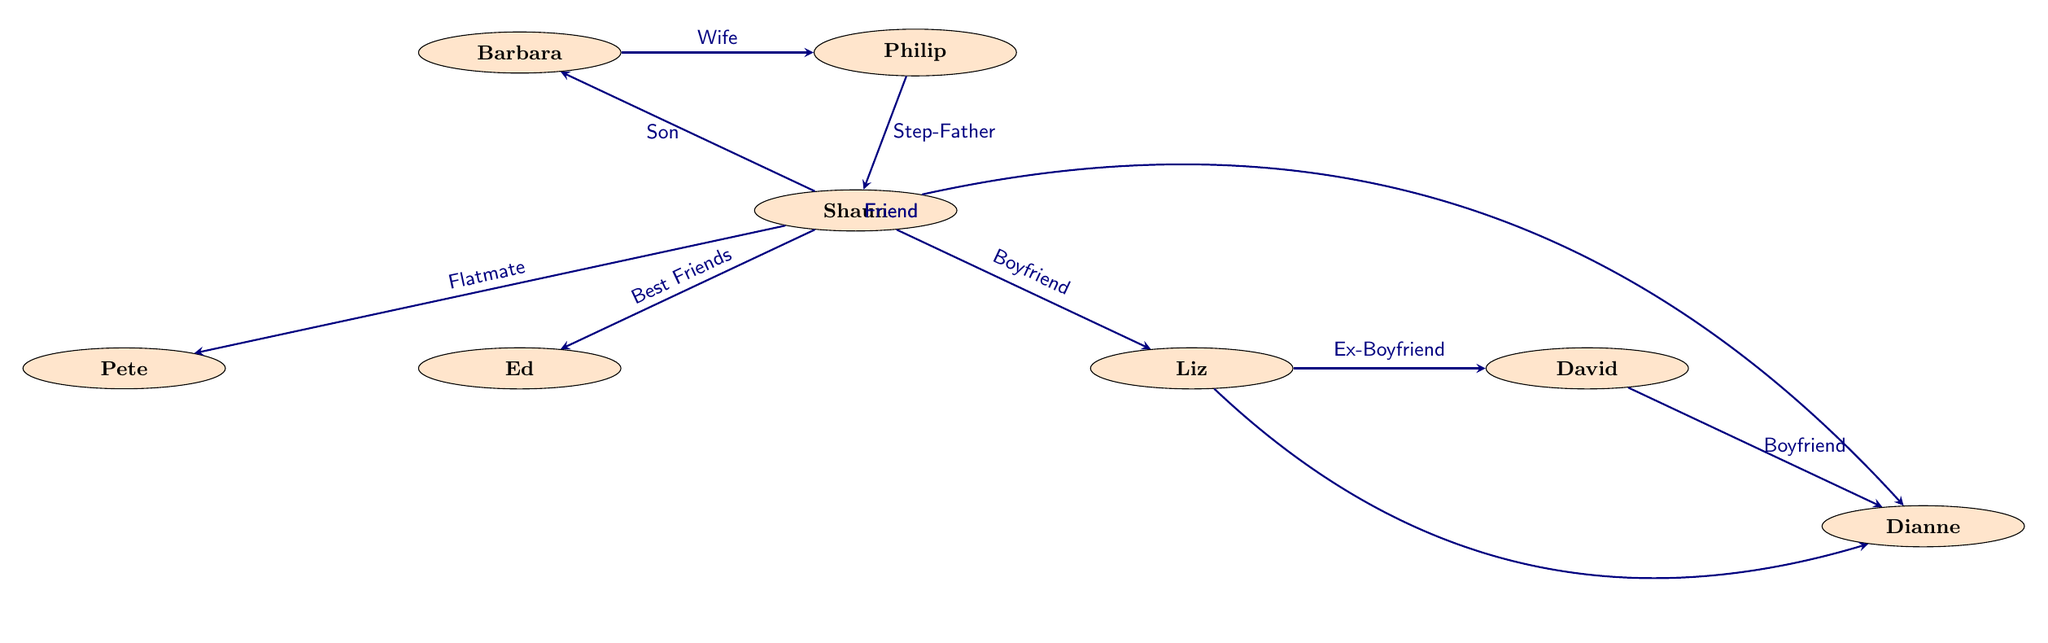What is the relationship between Shaun and Ed? The diagram indicates that Shaun and Ed have a "Best Friends" relationship. This information is directly displayed by the arrow connecting Shaun to Ed, labeled with the relationship type.
Answer: Best Friends How many characters are in the diagram? By counting the nodes labeled with character names, we find there are eight distinct characters represented in the diagram.
Answer: 8 What type of relationship exists between Liz and David? The diagram shows an arrow from Liz to David labeled "Ex-Boyfriend," indicating their previous romantic connection.
Answer: Ex-Boyfriend Who is Shaun's step-father? The diagram states that Philip is Shaun's step-father, as indicated by the arrow connecting Philip to Shaun labeled "Step-Father."
Answer: Philip Which character is both Shaun's flatmate and his friend? The diagram shows Shaun as having a flatmate relationship with Pete, while Dianne is noted as a friend of Shaun through a separate relationship arrow. However, only Pete is labeled as a flatmate. Thus, only Pete is Shaun's flatmate and he isn't labeled as a friend.
Answer: Pete How many relationships connect to Shaun? To find the total relationships, we count the arrows originating from Shaun in the diagram; these relationships connect Shaun to Ed, Liz, Barbara, Pete, Dianne. There are five outgoing relationships from Shaun.
Answer: 5 What is the relationship between Barbara and Philip? The diagram indicates that Barbara and Philip share a "Wife" relationship, evident from the connection arrow pointing from Barbara to Philip.
Answer: Wife Which character has a friendship with both Shaun and Liz? The diagram shows that Dianne is a friend to both Shaun and Liz, as indicated by the arrows connecting Dianne to each of these characters labeled "Friend."
Answer: Dianne 